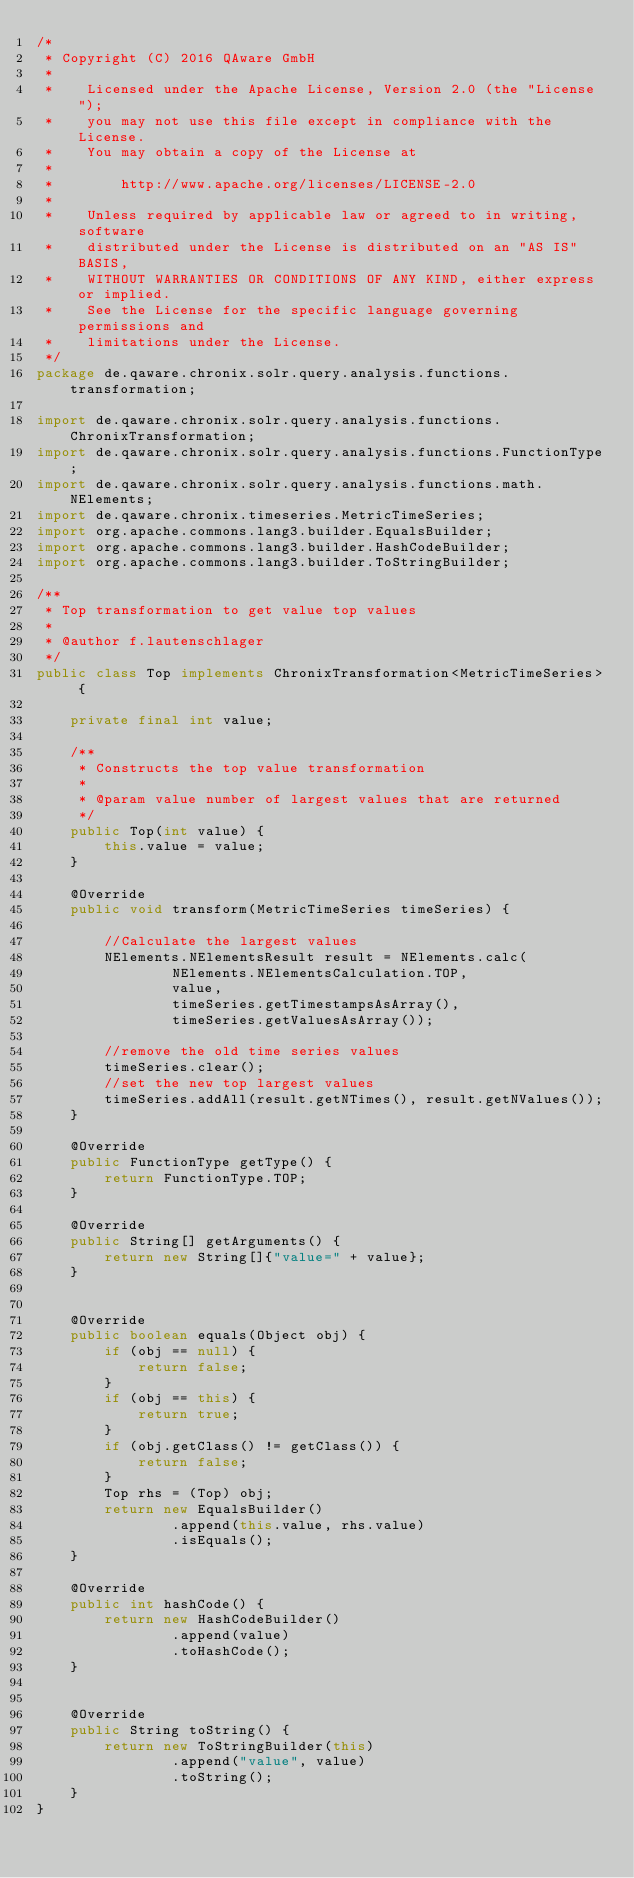Convert code to text. <code><loc_0><loc_0><loc_500><loc_500><_Java_>/*
 * Copyright (C) 2016 QAware GmbH
 *
 *    Licensed under the Apache License, Version 2.0 (the "License");
 *    you may not use this file except in compliance with the License.
 *    You may obtain a copy of the License at
 *
 *        http://www.apache.org/licenses/LICENSE-2.0
 *
 *    Unless required by applicable law or agreed to in writing, software
 *    distributed under the License is distributed on an "AS IS" BASIS,
 *    WITHOUT WARRANTIES OR CONDITIONS OF ANY KIND, either express or implied.
 *    See the License for the specific language governing permissions and
 *    limitations under the License.
 */
package de.qaware.chronix.solr.query.analysis.functions.transformation;

import de.qaware.chronix.solr.query.analysis.functions.ChronixTransformation;
import de.qaware.chronix.solr.query.analysis.functions.FunctionType;
import de.qaware.chronix.solr.query.analysis.functions.math.NElements;
import de.qaware.chronix.timeseries.MetricTimeSeries;
import org.apache.commons.lang3.builder.EqualsBuilder;
import org.apache.commons.lang3.builder.HashCodeBuilder;
import org.apache.commons.lang3.builder.ToStringBuilder;

/**
 * Top transformation to get value top values
 *
 * @author f.lautenschlager
 */
public class Top implements ChronixTransformation<MetricTimeSeries> {

    private final int value;

    /**
     * Constructs the top value transformation
     *
     * @param value number of largest values that are returned
     */
    public Top(int value) {
        this.value = value;
    }

    @Override
    public void transform(MetricTimeSeries timeSeries) {

        //Calculate the largest values
        NElements.NElementsResult result = NElements.calc(
                NElements.NElementsCalculation.TOP,
                value,
                timeSeries.getTimestampsAsArray(),
                timeSeries.getValuesAsArray());

        //remove the old time series values
        timeSeries.clear();
        //set the new top largest values
        timeSeries.addAll(result.getNTimes(), result.getNValues());
    }

    @Override
    public FunctionType getType() {
        return FunctionType.TOP;
    }

    @Override
    public String[] getArguments() {
        return new String[]{"value=" + value};
    }


    @Override
    public boolean equals(Object obj) {
        if (obj == null) {
            return false;
        }
        if (obj == this) {
            return true;
        }
        if (obj.getClass() != getClass()) {
            return false;
        }
        Top rhs = (Top) obj;
        return new EqualsBuilder()
                .append(this.value, rhs.value)
                .isEquals();
    }

    @Override
    public int hashCode() {
        return new HashCodeBuilder()
                .append(value)
                .toHashCode();
    }


    @Override
    public String toString() {
        return new ToStringBuilder(this)
                .append("value", value)
                .toString();
    }
}
</code> 